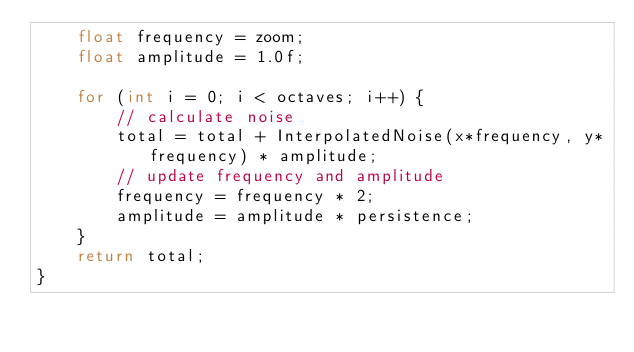Convert code to text. <code><loc_0><loc_0><loc_500><loc_500><_C++_>    float frequency = zoom;
    float amplitude = 1.0f;
 
    for (int i = 0; i < octaves; i++) {
        // calculate noise
        total = total + InterpolatedNoise(x*frequency, y*frequency) * amplitude;
        // update frequency and amplitude
        frequency = frequency * 2;
        amplitude = amplitude * persistence;
    }
    return total;
}</code> 